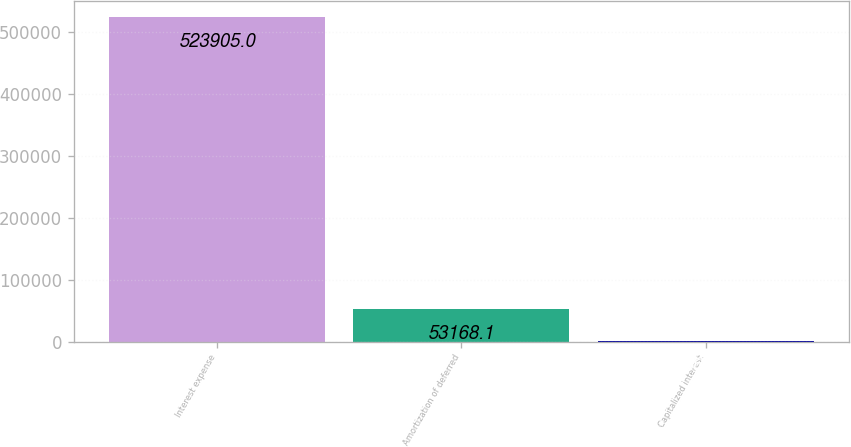Convert chart. <chart><loc_0><loc_0><loc_500><loc_500><bar_chart><fcel>Interest expense<fcel>Amortization of deferred<fcel>Capitalized interest<nl><fcel>523905<fcel>53168.1<fcel>864<nl></chart> 